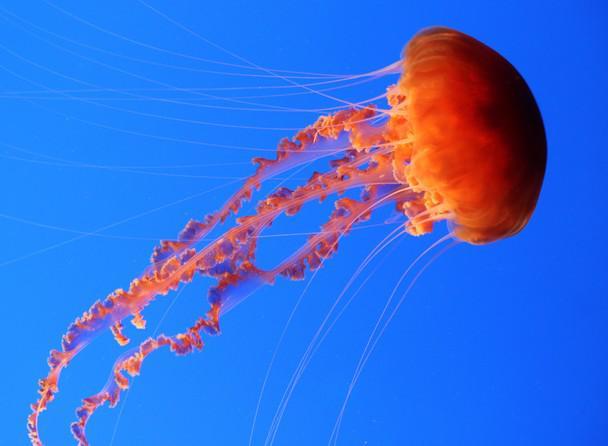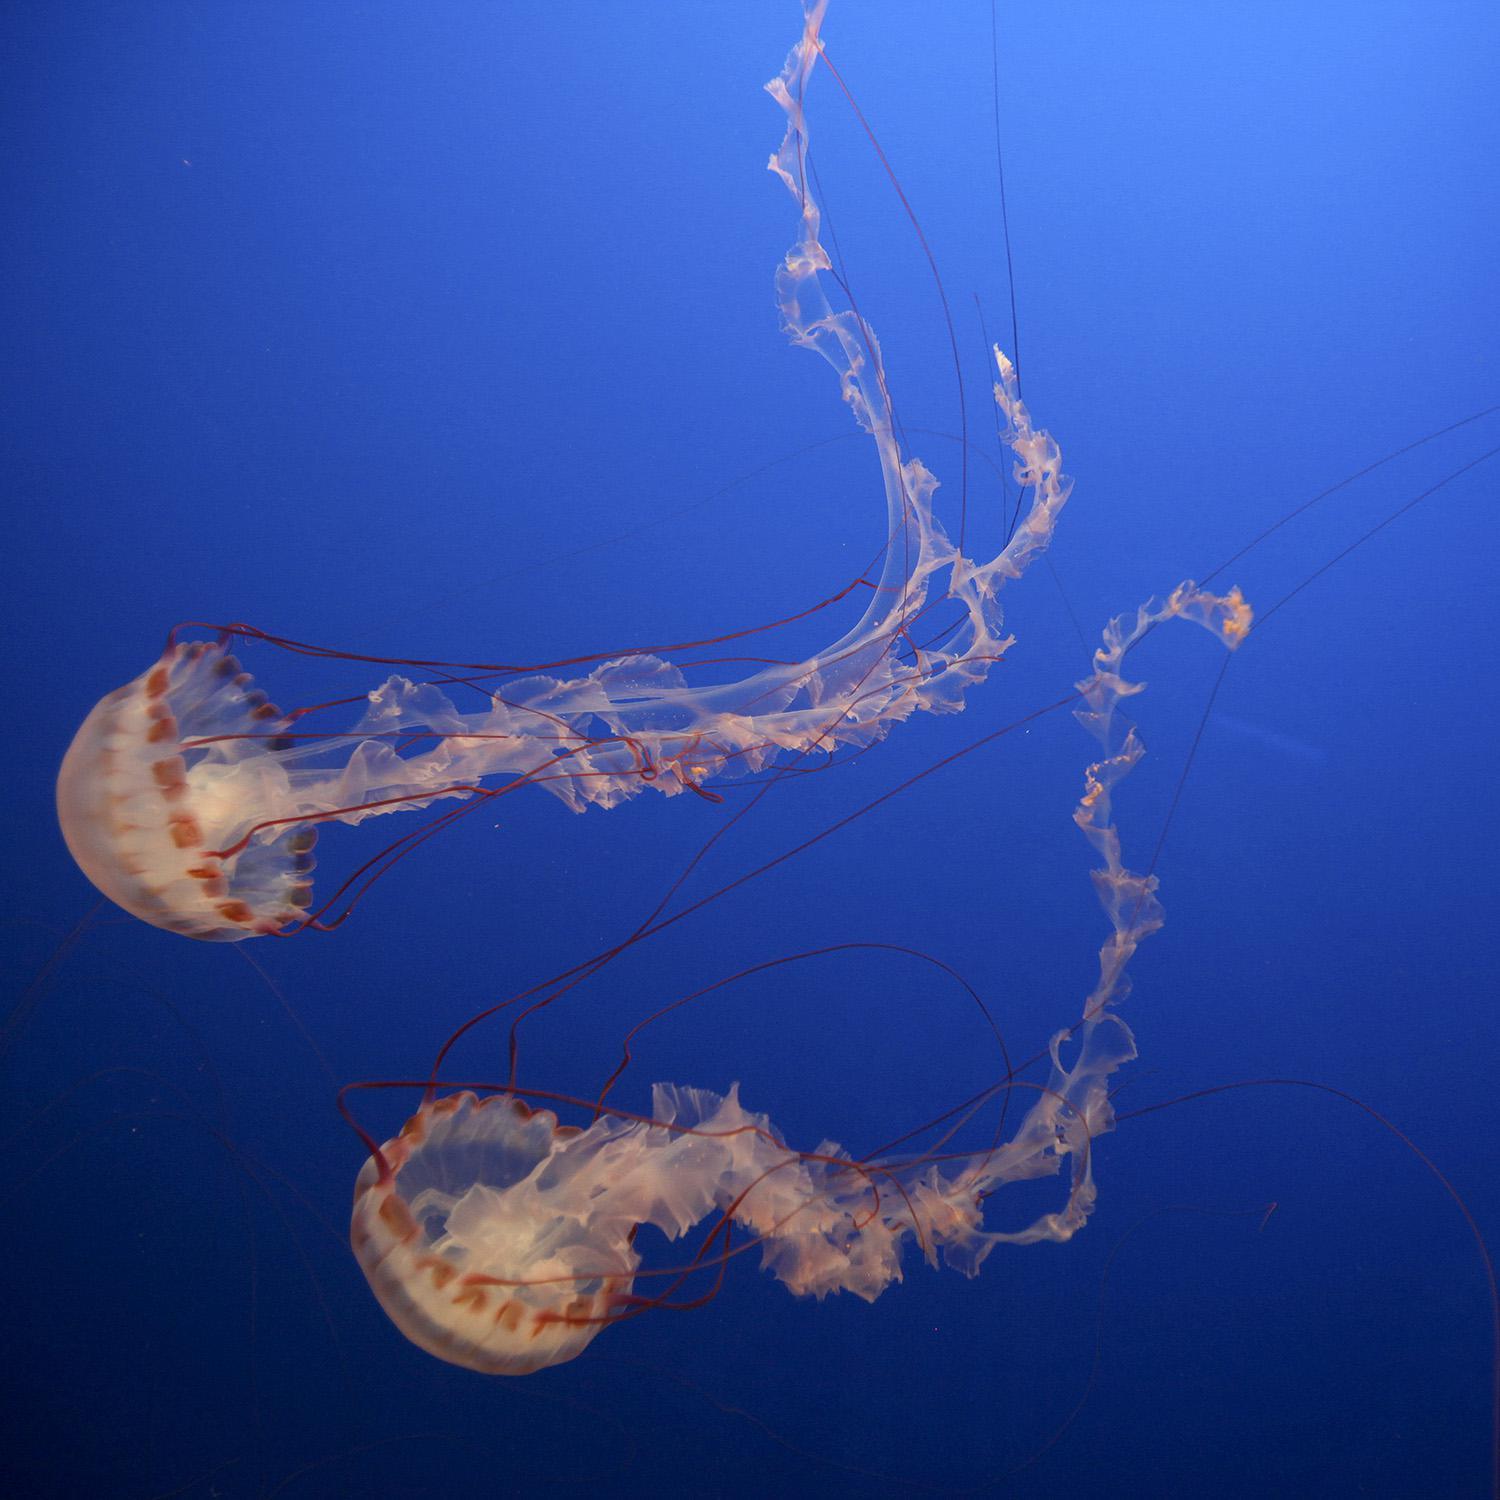The first image is the image on the left, the second image is the image on the right. For the images displayed, is the sentence "One jellyfish is swimming toward the right." factually correct? Answer yes or no. Yes. The first image is the image on the left, the second image is the image on the right. Analyze the images presented: Is the assertion "One image contains multiple jellyfish, and one image contains a single orange jellyfish with long 'ruffled' tendrils on a solid blue backdrop." valid? Answer yes or no. Yes. 